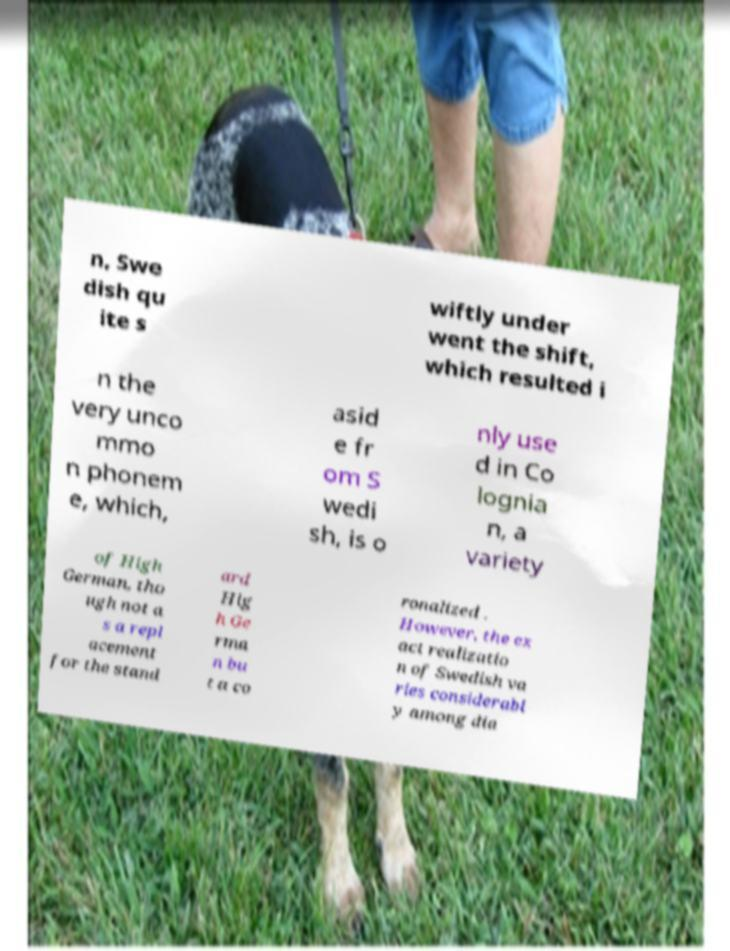Please read and relay the text visible in this image. What does it say? n, Swe dish qu ite s wiftly under went the shift, which resulted i n the very unco mmo n phonem e, which, asid e fr om S wedi sh, is o nly use d in Co lognia n, a variety of High German, tho ugh not a s a repl acement for the stand ard Hig h Ge rma n bu t a co ronalized . However, the ex act realizatio n of Swedish va ries considerabl y among dia 